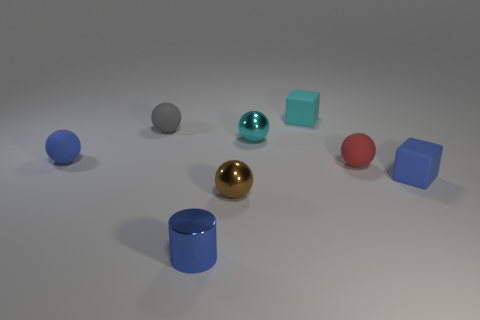There is a brown shiny object that is the same size as the red rubber thing; what is its shape?
Your answer should be very brief. Sphere. What is the shape of the small object that is in front of the brown shiny sphere?
Offer a terse response. Cylinder. There is a blue object on the right side of the small blue shiny cylinder; is there a matte block to the left of it?
Provide a short and direct response. Yes. Are there any yellow rubber objects of the same size as the gray matte ball?
Your answer should be compact. No. Is the color of the shiny sphere in front of the small cyan metal thing the same as the metallic cylinder?
Give a very brief answer. No. What size is the red matte sphere?
Provide a short and direct response. Small. What is the size of the thing on the left side of the small matte ball that is behind the small cyan ball?
Offer a terse response. Small. What number of small matte objects have the same color as the metallic cylinder?
Your response must be concise. 2. What number of tiny red objects are there?
Offer a very short reply. 1. How many large brown balls are the same material as the blue sphere?
Offer a terse response. 0. 